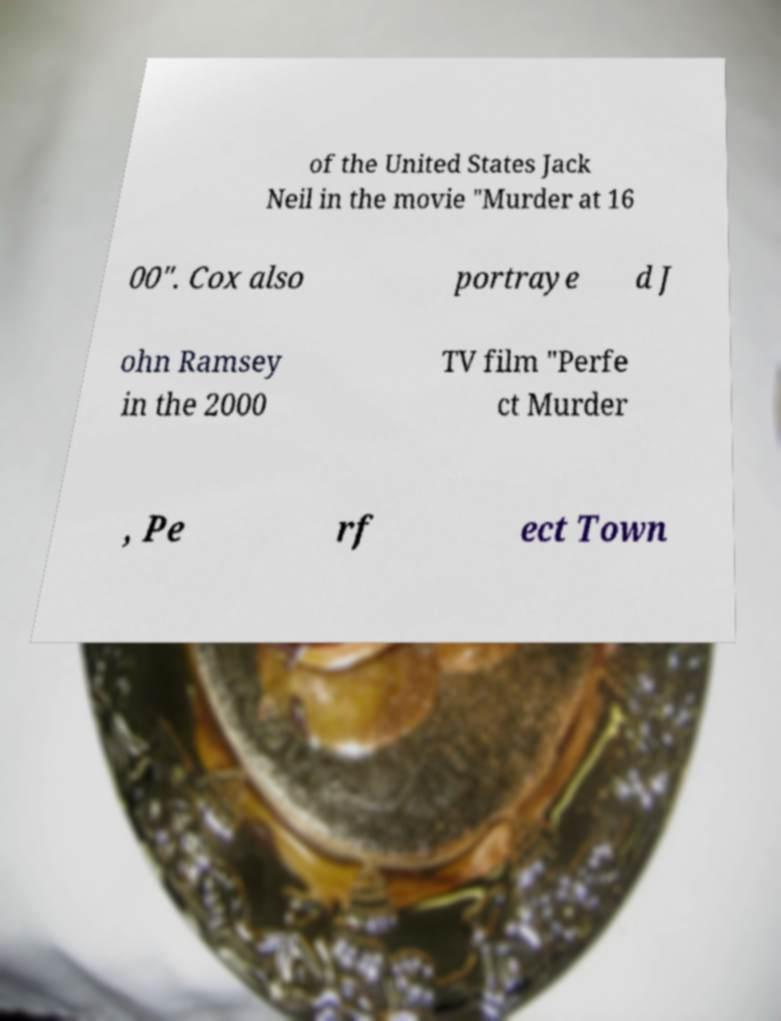Can you accurately transcribe the text from the provided image for me? of the United States Jack Neil in the movie "Murder at 16 00". Cox also portraye d J ohn Ramsey in the 2000 TV film "Perfe ct Murder , Pe rf ect Town 